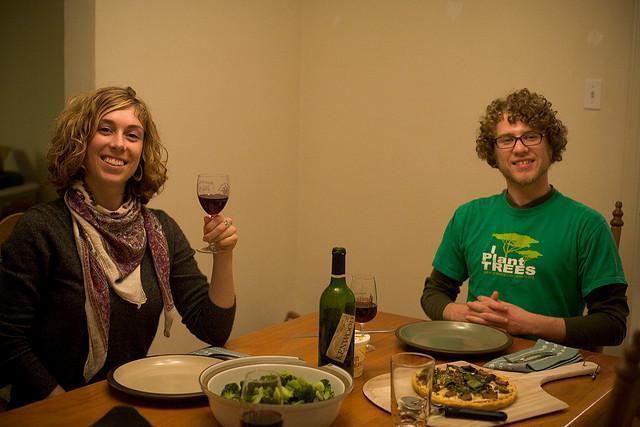How many pizzas are there?
Give a very brief answer. 1. How many people are there?
Give a very brief answer. 2. How many bikes have a helmet attached to the handlebar?
Give a very brief answer. 0. 